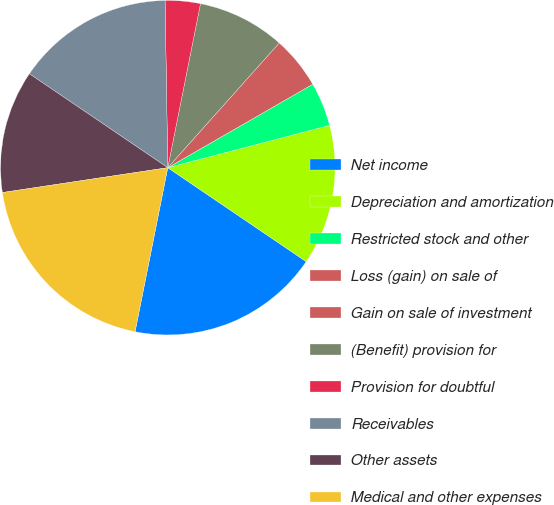Convert chart to OTSL. <chart><loc_0><loc_0><loc_500><loc_500><pie_chart><fcel>Net income<fcel>Depreciation and amortization<fcel>Restricted stock and other<fcel>Loss (gain) on sale of<fcel>Gain on sale of investment<fcel>(Benefit) provision for<fcel>Provision for doubtful<fcel>Receivables<fcel>Other assets<fcel>Medical and other expenses<nl><fcel>18.64%<fcel>13.56%<fcel>4.24%<fcel>0.0%<fcel>5.08%<fcel>8.47%<fcel>3.39%<fcel>15.25%<fcel>11.86%<fcel>19.49%<nl></chart> 